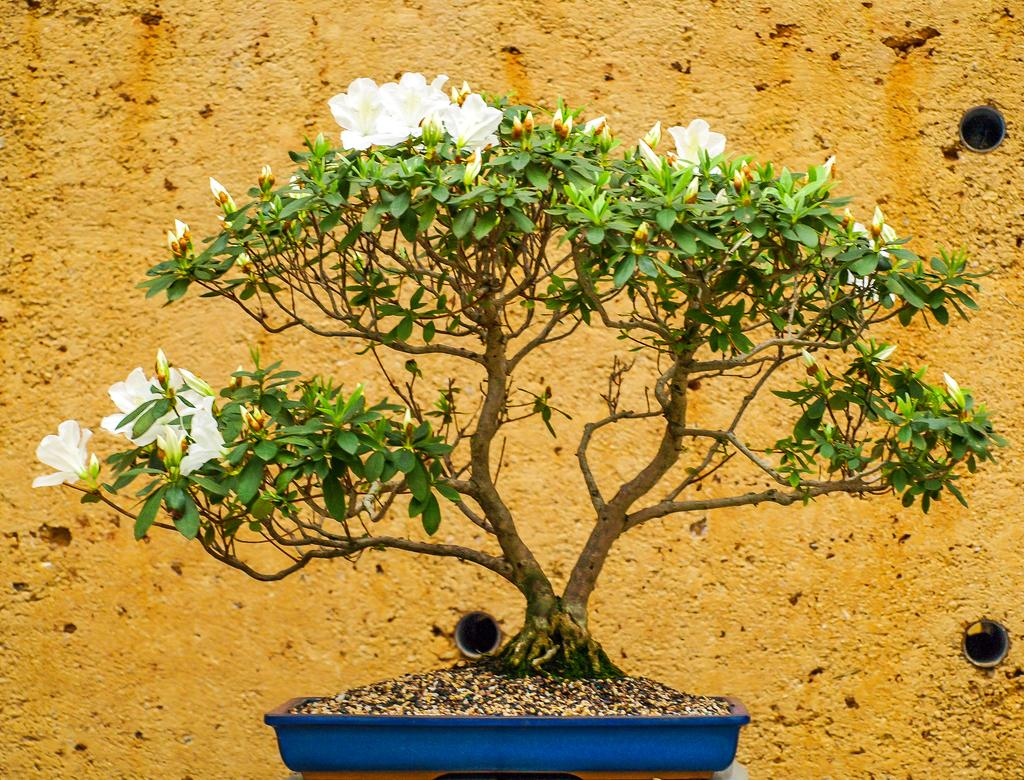What type of plant is in the image? There is a small plant in the image. What color are the leaves of the plant? The plant has green leaves. What color are the flowers of the plant? The plant has white flowers. What color is the wall in the background of the image? There is an orange color wall in the background of the image. What type of butter is being used to paint the pipe in the image? There is no butter or pipe present in the image; it features a small plant with green leaves and white flowers in front of an orange color wall. 